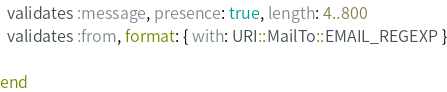Convert code to text. <code><loc_0><loc_0><loc_500><loc_500><_Ruby_>
  validates :message, presence: true, length: 4..800
  validates :from, format: { with: URI::MailTo::EMAIL_REGEXP }

end

</code> 